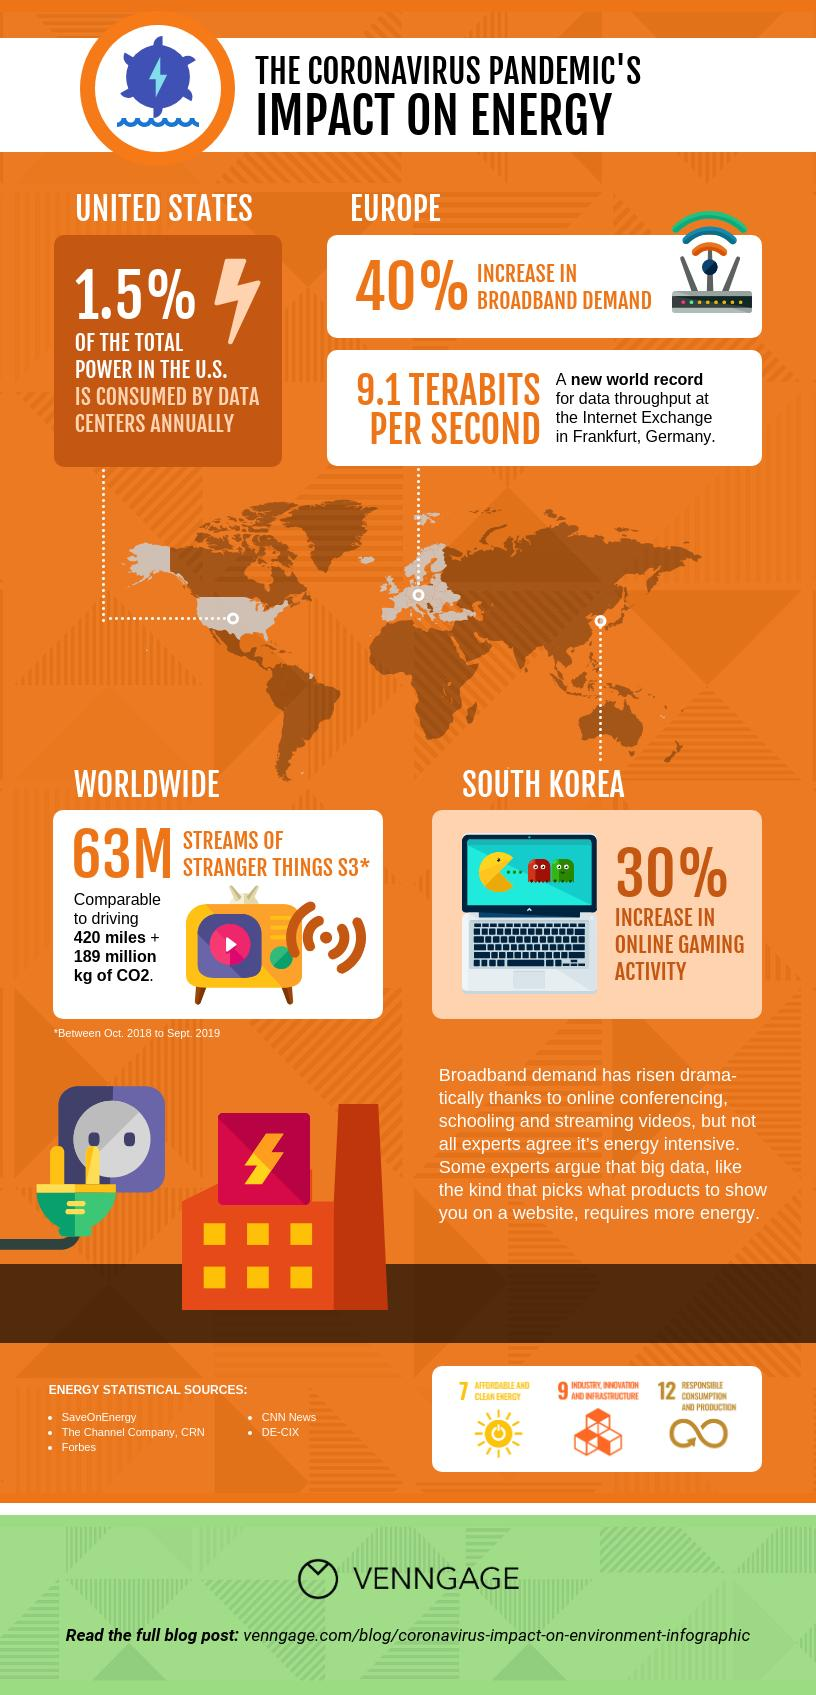Point out several critical features in this image. Five energy statistical sources have been provided. 